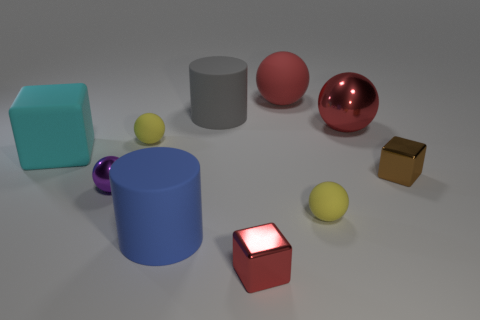There is a tiny matte object that is right of the large gray object; is it the same shape as the cyan thing?
Your response must be concise. No. What number of purple metal things have the same size as the brown cube?
Keep it short and to the point. 1. How many yellow spheres are to the left of the yellow sphere on the right side of the blue rubber cylinder?
Your response must be concise. 1. Is the material of the cyan block that is behind the small brown metal block the same as the large gray cylinder?
Offer a very short reply. Yes. Are the large cylinder behind the purple metallic thing and the small sphere right of the big gray thing made of the same material?
Your answer should be very brief. Yes. Are there more big shiny objects that are in front of the big shiny object than metallic things?
Offer a very short reply. No. There is a rubber object that is left of the tiny yellow ball that is behind the purple object; what is its color?
Ensure brevity in your answer.  Cyan. What is the shape of the red shiny thing that is the same size as the red rubber sphere?
Keep it short and to the point. Sphere. The tiny object that is the same color as the big matte ball is what shape?
Your response must be concise. Cube. Are there the same number of tiny spheres behind the big red rubber sphere and purple objects?
Offer a very short reply. No. 